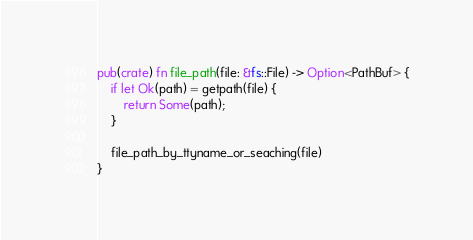Convert code to text. <code><loc_0><loc_0><loc_500><loc_500><_Rust_>
pub(crate) fn file_path(file: &fs::File) -> Option<PathBuf> {
    if let Ok(path) = getpath(file) {
        return Some(path);
    }

    file_path_by_ttyname_or_seaching(file)
}
</code> 